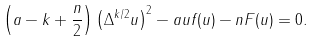Convert formula to latex. <formula><loc_0><loc_0><loc_500><loc_500>\left ( a - k + \frac { n } { 2 } \right ) \left ( { \Delta } ^ { k / 2 } u \right ) ^ { 2 } - a u f ( u ) - n F ( u ) = 0 .</formula> 